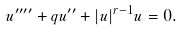<formula> <loc_0><loc_0><loc_500><loc_500>u ^ { \prime \prime \prime \prime } + q u ^ { \prime \prime } + | u | ^ { r - 1 } u = 0 .</formula> 